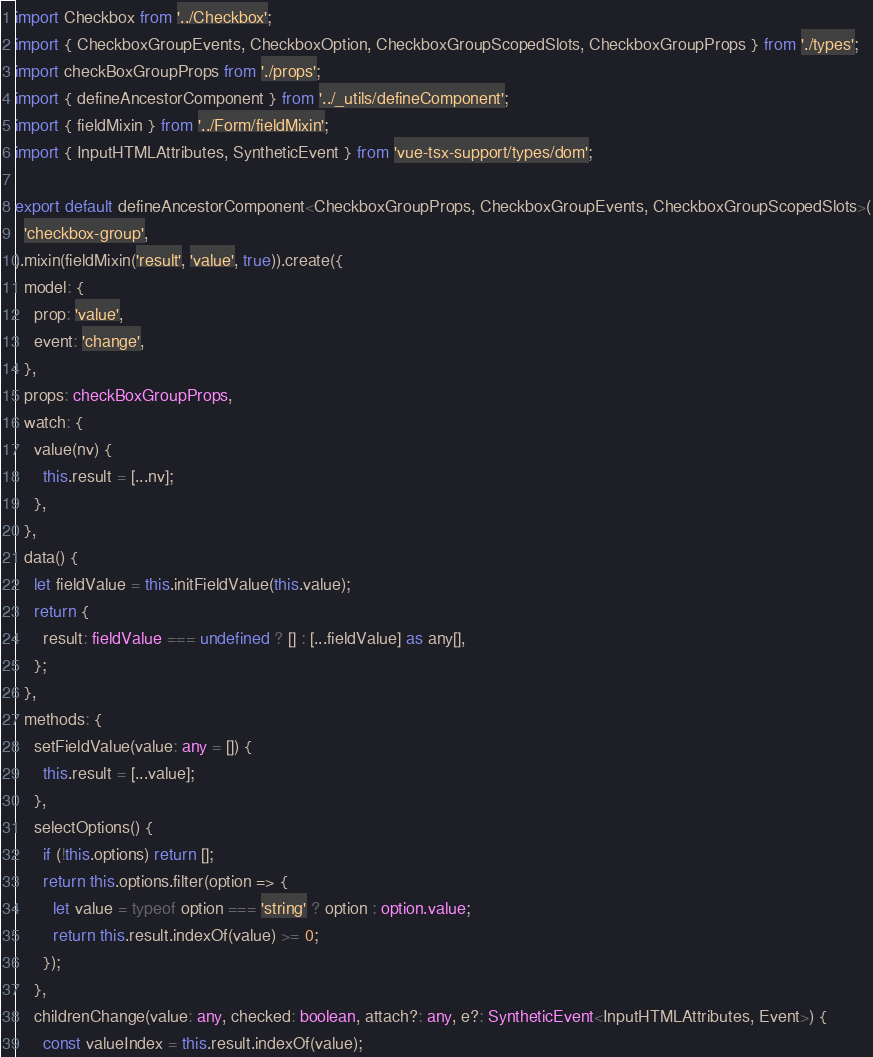Convert code to text. <code><loc_0><loc_0><loc_500><loc_500><_TypeScript_>import Checkbox from '../Checkbox';
import { CheckboxGroupEvents, CheckboxOption, CheckboxGroupScopedSlots, CheckboxGroupProps } from './types';
import checkBoxGroupProps from './props';
import { defineAncestorComponent } from '../_utils/defineComponent';
import { fieldMixin } from '../Form/fieldMixin';
import { InputHTMLAttributes, SyntheticEvent } from 'vue-tsx-support/types/dom';

export default defineAncestorComponent<CheckboxGroupProps, CheckboxGroupEvents, CheckboxGroupScopedSlots>(
  'checkbox-group',
).mixin(fieldMixin('result', 'value', true)).create({
  model: {
    prop: 'value',
    event: 'change',
  },
  props: checkBoxGroupProps,
  watch: {
    value(nv) {
      this.result = [...nv];
    },
  },
  data() {
    let fieldValue = this.initFieldValue(this.value);
    return {
      result: fieldValue === undefined ? [] : [...fieldValue] as any[],
    };
  },
  methods: {
    setFieldValue(value: any = []) {
      this.result = [...value];
    },
    selectOptions() {
      if (!this.options) return [];
      return this.options.filter(option => {
        let value = typeof option === 'string' ? option : option.value;
        return this.result.indexOf(value) >= 0;
      });
    },
    childrenChange(value: any, checked: boolean, attach?: any, e?: SyntheticEvent<InputHTMLAttributes, Event>) {
      const valueIndex = this.result.indexOf(value);</code> 